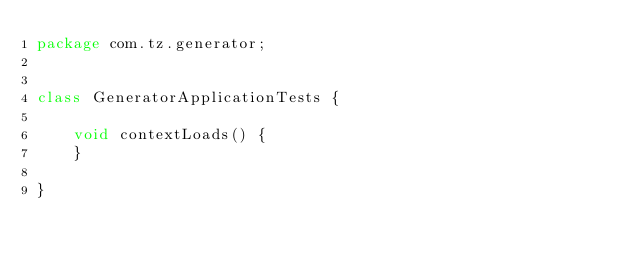<code> <loc_0><loc_0><loc_500><loc_500><_Java_>package com.tz.generator;


class GeneratorApplicationTests {

    void contextLoads() {
    }

}
</code> 